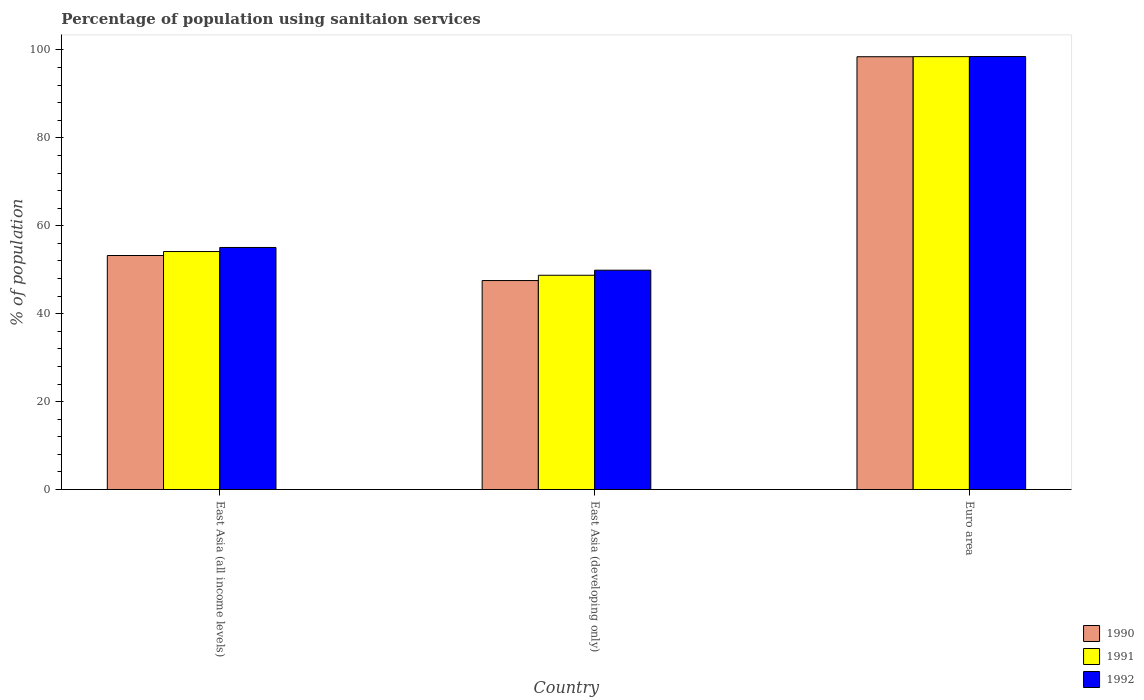Are the number of bars on each tick of the X-axis equal?
Give a very brief answer. Yes. How many bars are there on the 3rd tick from the left?
Offer a very short reply. 3. How many bars are there on the 1st tick from the right?
Your answer should be compact. 3. What is the label of the 1st group of bars from the left?
Your answer should be compact. East Asia (all income levels). In how many cases, is the number of bars for a given country not equal to the number of legend labels?
Ensure brevity in your answer.  0. What is the percentage of population using sanitaion services in 1991 in Euro area?
Your answer should be compact. 98.47. Across all countries, what is the maximum percentage of population using sanitaion services in 1992?
Offer a terse response. 98.5. Across all countries, what is the minimum percentage of population using sanitaion services in 1991?
Keep it short and to the point. 48.74. In which country was the percentage of population using sanitaion services in 1991 maximum?
Ensure brevity in your answer.  Euro area. In which country was the percentage of population using sanitaion services in 1990 minimum?
Make the answer very short. East Asia (developing only). What is the total percentage of population using sanitaion services in 1991 in the graph?
Your answer should be compact. 201.35. What is the difference between the percentage of population using sanitaion services in 1992 in East Asia (all income levels) and that in East Asia (developing only)?
Offer a terse response. 5.17. What is the difference between the percentage of population using sanitaion services in 1991 in Euro area and the percentage of population using sanitaion services in 1992 in East Asia (developing only)?
Your answer should be very brief. 48.58. What is the average percentage of population using sanitaion services in 1990 per country?
Keep it short and to the point. 66.41. What is the difference between the percentage of population using sanitaion services of/in 1992 and percentage of population using sanitaion services of/in 1991 in Euro area?
Your answer should be compact. 0.02. What is the ratio of the percentage of population using sanitaion services in 1990 in East Asia (all income levels) to that in East Asia (developing only)?
Offer a terse response. 1.12. Is the difference between the percentage of population using sanitaion services in 1992 in East Asia (all income levels) and Euro area greater than the difference between the percentage of population using sanitaion services in 1991 in East Asia (all income levels) and Euro area?
Ensure brevity in your answer.  Yes. What is the difference between the highest and the second highest percentage of population using sanitaion services in 1990?
Your answer should be very brief. 45.21. What is the difference between the highest and the lowest percentage of population using sanitaion services in 1992?
Offer a terse response. 48.6. What does the 1st bar from the left in East Asia (all income levels) represents?
Give a very brief answer. 1990. Is it the case that in every country, the sum of the percentage of population using sanitaion services in 1990 and percentage of population using sanitaion services in 1992 is greater than the percentage of population using sanitaion services in 1991?
Your answer should be very brief. Yes. How many countries are there in the graph?
Ensure brevity in your answer.  3. Are the values on the major ticks of Y-axis written in scientific E-notation?
Provide a succinct answer. No. How many legend labels are there?
Your response must be concise. 3. What is the title of the graph?
Your answer should be compact. Percentage of population using sanitaion services. What is the label or title of the X-axis?
Keep it short and to the point. Country. What is the label or title of the Y-axis?
Your response must be concise. % of population. What is the % of population of 1990 in East Asia (all income levels)?
Provide a succinct answer. 53.23. What is the % of population of 1991 in East Asia (all income levels)?
Offer a terse response. 54.13. What is the % of population of 1992 in East Asia (all income levels)?
Ensure brevity in your answer.  55.06. What is the % of population in 1990 in East Asia (developing only)?
Ensure brevity in your answer.  47.53. What is the % of population in 1991 in East Asia (developing only)?
Offer a very short reply. 48.74. What is the % of population in 1992 in East Asia (developing only)?
Give a very brief answer. 49.89. What is the % of population in 1990 in Euro area?
Ensure brevity in your answer.  98.45. What is the % of population in 1991 in Euro area?
Offer a very short reply. 98.47. What is the % of population in 1992 in Euro area?
Provide a short and direct response. 98.5. Across all countries, what is the maximum % of population of 1990?
Your response must be concise. 98.45. Across all countries, what is the maximum % of population in 1991?
Your answer should be compact. 98.47. Across all countries, what is the maximum % of population in 1992?
Provide a succinct answer. 98.5. Across all countries, what is the minimum % of population of 1990?
Provide a succinct answer. 47.53. Across all countries, what is the minimum % of population of 1991?
Make the answer very short. 48.74. Across all countries, what is the minimum % of population in 1992?
Provide a short and direct response. 49.89. What is the total % of population of 1990 in the graph?
Keep it short and to the point. 199.22. What is the total % of population of 1991 in the graph?
Keep it short and to the point. 201.35. What is the total % of population in 1992 in the graph?
Provide a short and direct response. 203.45. What is the difference between the % of population of 1990 in East Asia (all income levels) and that in East Asia (developing only)?
Your answer should be compact. 5.7. What is the difference between the % of population in 1991 in East Asia (all income levels) and that in East Asia (developing only)?
Offer a very short reply. 5.39. What is the difference between the % of population in 1992 in East Asia (all income levels) and that in East Asia (developing only)?
Keep it short and to the point. 5.17. What is the difference between the % of population of 1990 in East Asia (all income levels) and that in Euro area?
Provide a succinct answer. -45.21. What is the difference between the % of population in 1991 in East Asia (all income levels) and that in Euro area?
Offer a terse response. -44.34. What is the difference between the % of population in 1992 in East Asia (all income levels) and that in Euro area?
Keep it short and to the point. -43.44. What is the difference between the % of population in 1990 in East Asia (developing only) and that in Euro area?
Keep it short and to the point. -50.91. What is the difference between the % of population of 1991 in East Asia (developing only) and that in Euro area?
Offer a terse response. -49.73. What is the difference between the % of population in 1992 in East Asia (developing only) and that in Euro area?
Keep it short and to the point. -48.6. What is the difference between the % of population of 1990 in East Asia (all income levels) and the % of population of 1991 in East Asia (developing only)?
Your response must be concise. 4.49. What is the difference between the % of population in 1990 in East Asia (all income levels) and the % of population in 1992 in East Asia (developing only)?
Offer a very short reply. 3.34. What is the difference between the % of population in 1991 in East Asia (all income levels) and the % of population in 1992 in East Asia (developing only)?
Give a very brief answer. 4.24. What is the difference between the % of population in 1990 in East Asia (all income levels) and the % of population in 1991 in Euro area?
Provide a short and direct response. -45.24. What is the difference between the % of population in 1990 in East Asia (all income levels) and the % of population in 1992 in Euro area?
Provide a succinct answer. -45.26. What is the difference between the % of population of 1991 in East Asia (all income levels) and the % of population of 1992 in Euro area?
Give a very brief answer. -44.36. What is the difference between the % of population of 1990 in East Asia (developing only) and the % of population of 1991 in Euro area?
Your response must be concise. -50.94. What is the difference between the % of population in 1990 in East Asia (developing only) and the % of population in 1992 in Euro area?
Provide a short and direct response. -50.96. What is the difference between the % of population in 1991 in East Asia (developing only) and the % of population in 1992 in Euro area?
Provide a short and direct response. -49.75. What is the average % of population of 1990 per country?
Ensure brevity in your answer.  66.41. What is the average % of population in 1991 per country?
Offer a terse response. 67.12. What is the average % of population of 1992 per country?
Ensure brevity in your answer.  67.82. What is the difference between the % of population of 1990 and % of population of 1991 in East Asia (all income levels)?
Make the answer very short. -0.9. What is the difference between the % of population of 1990 and % of population of 1992 in East Asia (all income levels)?
Your answer should be compact. -1.83. What is the difference between the % of population in 1991 and % of population in 1992 in East Asia (all income levels)?
Offer a very short reply. -0.93. What is the difference between the % of population in 1990 and % of population in 1991 in East Asia (developing only)?
Keep it short and to the point. -1.21. What is the difference between the % of population of 1990 and % of population of 1992 in East Asia (developing only)?
Provide a succinct answer. -2.36. What is the difference between the % of population in 1991 and % of population in 1992 in East Asia (developing only)?
Provide a succinct answer. -1.15. What is the difference between the % of population of 1990 and % of population of 1991 in Euro area?
Provide a succinct answer. -0.02. What is the difference between the % of population of 1990 and % of population of 1992 in Euro area?
Provide a succinct answer. -0.05. What is the difference between the % of population in 1991 and % of population in 1992 in Euro area?
Offer a very short reply. -0.02. What is the ratio of the % of population of 1990 in East Asia (all income levels) to that in East Asia (developing only)?
Make the answer very short. 1.12. What is the ratio of the % of population in 1991 in East Asia (all income levels) to that in East Asia (developing only)?
Offer a very short reply. 1.11. What is the ratio of the % of population in 1992 in East Asia (all income levels) to that in East Asia (developing only)?
Ensure brevity in your answer.  1.1. What is the ratio of the % of population of 1990 in East Asia (all income levels) to that in Euro area?
Provide a succinct answer. 0.54. What is the ratio of the % of population of 1991 in East Asia (all income levels) to that in Euro area?
Make the answer very short. 0.55. What is the ratio of the % of population in 1992 in East Asia (all income levels) to that in Euro area?
Ensure brevity in your answer.  0.56. What is the ratio of the % of population of 1990 in East Asia (developing only) to that in Euro area?
Give a very brief answer. 0.48. What is the ratio of the % of population of 1991 in East Asia (developing only) to that in Euro area?
Offer a very short reply. 0.49. What is the ratio of the % of population in 1992 in East Asia (developing only) to that in Euro area?
Give a very brief answer. 0.51. What is the difference between the highest and the second highest % of population of 1990?
Offer a very short reply. 45.21. What is the difference between the highest and the second highest % of population in 1991?
Provide a short and direct response. 44.34. What is the difference between the highest and the second highest % of population of 1992?
Give a very brief answer. 43.44. What is the difference between the highest and the lowest % of population in 1990?
Keep it short and to the point. 50.91. What is the difference between the highest and the lowest % of population of 1991?
Offer a terse response. 49.73. What is the difference between the highest and the lowest % of population of 1992?
Your answer should be compact. 48.6. 